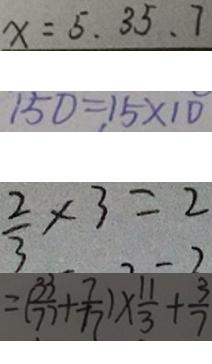<formula> <loc_0><loc_0><loc_500><loc_500>x = 5 . 3 5 . 7 
 1 5 0 = 1 5 \times 1 0 
 \frac { 2 } { 3 } \times 3 = 2 
 = ( \frac { 3 3 } { 7 7 } + \frac { 7 } { 7 7 } ) \times \frac { 1 1 } { 3 } + \frac { 3 } { 7 }</formula> 